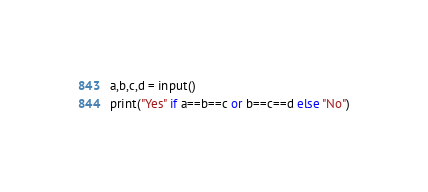Convert code to text. <code><loc_0><loc_0><loc_500><loc_500><_Python_>a,b,c,d = input()
print("Yes" if a==b==c or b==c==d else "No")</code> 